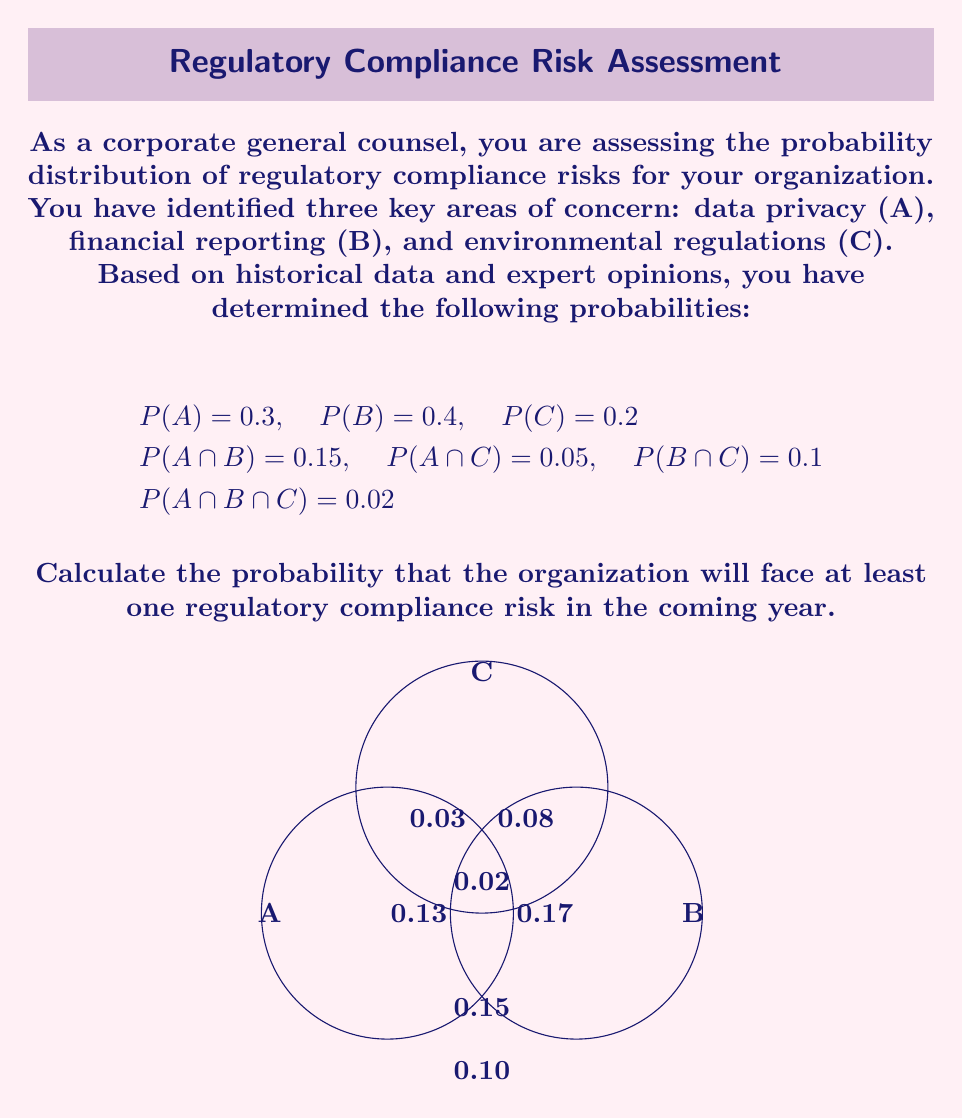Could you help me with this problem? To solve this problem, we'll use the concept of probability of the union of events and the Inclusion-Exclusion Principle.

Step 1: Define the event we're looking for
Let E be the event that the organization faces at least one regulatory compliance risk. This is equivalent to the union of events A, B, and C.

$E = A ∪ B ∪ C$

Step 2: Apply the Inclusion-Exclusion Principle
The probability of the union of three events is given by:

$P(A ∪ B ∪ C) = P(A) + P(B) + P(C) - P(A ∩ B) - P(A ∩ C) - P(B ∩ C) + P(A ∩ B ∩ C)$

Step 3: Substitute the given probabilities
$P(E) = 0.3 + 0.4 + 0.2 - 0.15 - 0.05 - 0.1 + 0.02$

Step 4: Calculate the result
$P(E) = 0.9 - 0.3 + 0.02 = 0.62$

Therefore, the probability that the organization will face at least one regulatory compliance risk in the coming year is 0.62 or 62%.
Answer: 0.62 